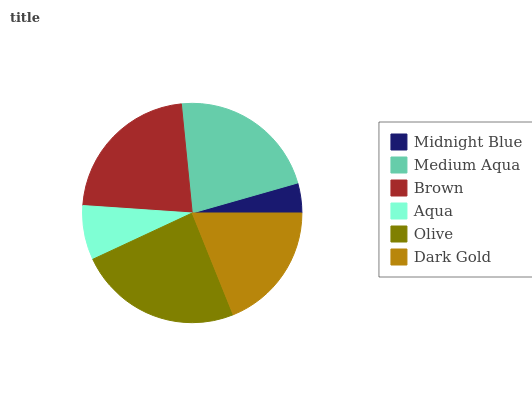Is Midnight Blue the minimum?
Answer yes or no. Yes. Is Olive the maximum?
Answer yes or no. Yes. Is Medium Aqua the minimum?
Answer yes or no. No. Is Medium Aqua the maximum?
Answer yes or no. No. Is Medium Aqua greater than Midnight Blue?
Answer yes or no. Yes. Is Midnight Blue less than Medium Aqua?
Answer yes or no. Yes. Is Midnight Blue greater than Medium Aqua?
Answer yes or no. No. Is Medium Aqua less than Midnight Blue?
Answer yes or no. No. Is Medium Aqua the high median?
Answer yes or no. Yes. Is Dark Gold the low median?
Answer yes or no. Yes. Is Olive the high median?
Answer yes or no. No. Is Midnight Blue the low median?
Answer yes or no. No. 